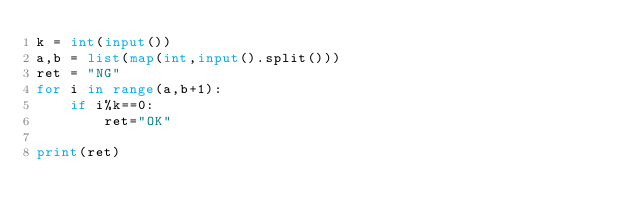Convert code to text. <code><loc_0><loc_0><loc_500><loc_500><_Python_>k = int(input())
a,b = list(map(int,input().split()))
ret = "NG"
for i in range(a,b+1):
    if i%k==0:
        ret="OK"

print(ret)</code> 